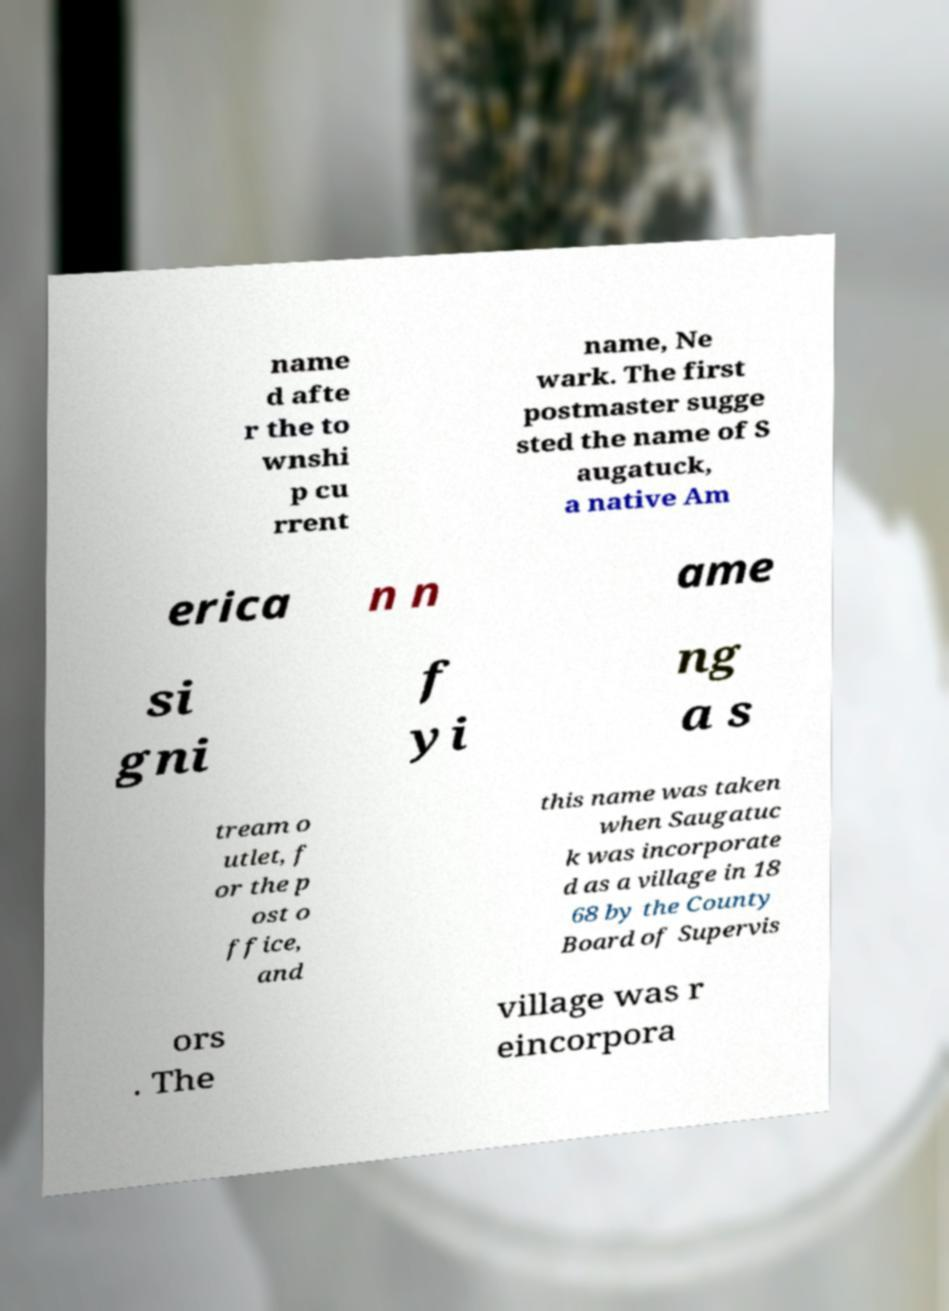I need the written content from this picture converted into text. Can you do that? name d afte r the to wnshi p cu rrent name, Ne wark. The first postmaster sugge sted the name of S augatuck, a native Am erica n n ame si gni f yi ng a s tream o utlet, f or the p ost o ffice, and this name was taken when Saugatuc k was incorporate d as a village in 18 68 by the County Board of Supervis ors . The village was r eincorpora 